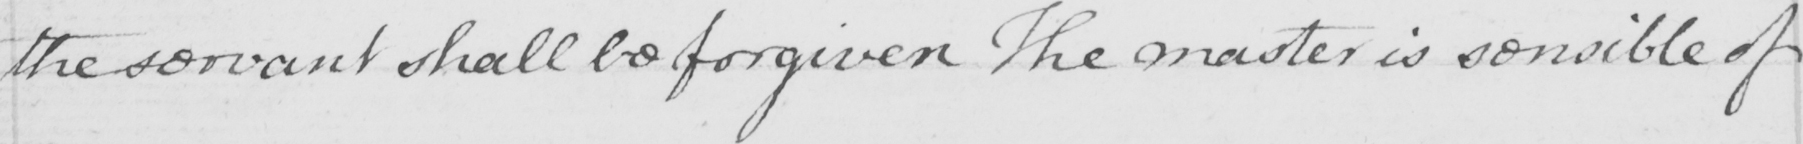What does this handwritten line say? the servant shall be forgiven . The master is sensible of 